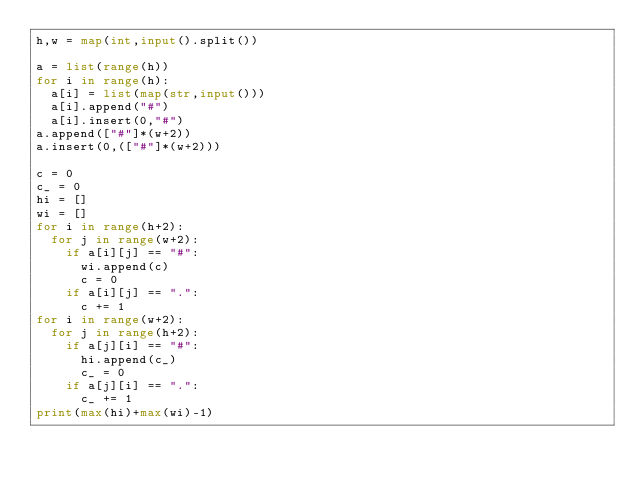<code> <loc_0><loc_0><loc_500><loc_500><_Python_>h,w = map(int,input().split())

a = list(range(h))
for i in range(h):
  a[i] = list(map(str,input()))
  a[i].append("#")
  a[i].insert(0,"#")
a.append(["#"]*(w+2))
a.insert(0,(["#"]*(w+2)))

c = 0
c_ = 0
hi = []
wi = []
for i in range(h+2):
  for j in range(w+2):
    if a[i][j] == "#":
      wi.append(c)
      c = 0
    if a[i][j] == ".":
      c += 1
for i in range(w+2):
  for j in range(h+2):    
    if a[j][i] == "#":
      hi.append(c_)
      c_ = 0
    if a[j][i] == ".":
      c_ += 1
print(max(hi)+max(wi)-1)</code> 